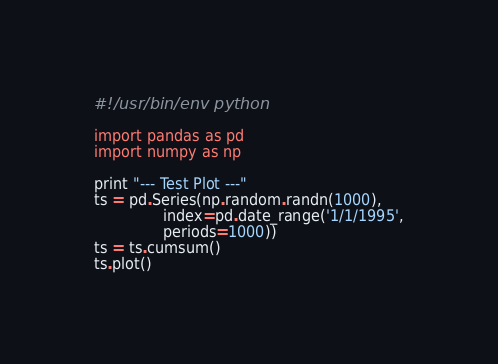Convert code to text. <code><loc_0><loc_0><loc_500><loc_500><_Python_>#!/usr/bin/env python

import pandas as pd
import numpy as np

print "--- Test Plot ---"
ts = pd.Series(np.random.randn(1000),
               index=pd.date_range('1/1/1995',
               periods=1000))
ts = ts.cumsum()
ts.plot()</code> 